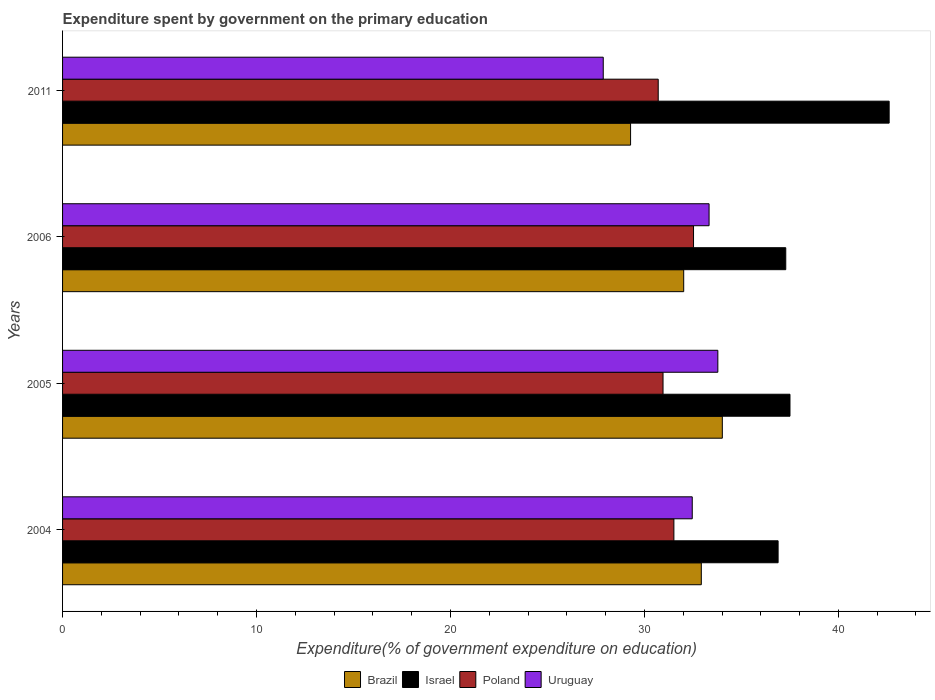How many different coloured bars are there?
Your response must be concise. 4. How many groups of bars are there?
Your answer should be very brief. 4. Are the number of bars per tick equal to the number of legend labels?
Provide a succinct answer. Yes. What is the expenditure spent by government on the primary education in Israel in 2005?
Provide a short and direct response. 37.5. Across all years, what is the maximum expenditure spent by government on the primary education in Brazil?
Provide a short and direct response. 34.02. Across all years, what is the minimum expenditure spent by government on the primary education in Uruguay?
Your answer should be very brief. 27.88. In which year was the expenditure spent by government on the primary education in Israel maximum?
Ensure brevity in your answer.  2011. What is the total expenditure spent by government on the primary education in Brazil in the graph?
Ensure brevity in your answer.  128.26. What is the difference between the expenditure spent by government on the primary education in Israel in 2005 and that in 2006?
Provide a succinct answer. 0.22. What is the difference between the expenditure spent by government on the primary education in Brazil in 2004 and the expenditure spent by government on the primary education in Uruguay in 2006?
Keep it short and to the point. -0.4. What is the average expenditure spent by government on the primary education in Poland per year?
Provide a succinct answer. 31.43. In the year 2011, what is the difference between the expenditure spent by government on the primary education in Poland and expenditure spent by government on the primary education in Israel?
Offer a very short reply. -11.91. In how many years, is the expenditure spent by government on the primary education in Uruguay greater than 6 %?
Provide a succinct answer. 4. What is the ratio of the expenditure spent by government on the primary education in Brazil in 2004 to that in 2006?
Provide a short and direct response. 1.03. Is the difference between the expenditure spent by government on the primary education in Poland in 2004 and 2006 greater than the difference between the expenditure spent by government on the primary education in Israel in 2004 and 2006?
Your answer should be very brief. No. What is the difference between the highest and the second highest expenditure spent by government on the primary education in Poland?
Your answer should be compact. 1.01. What is the difference between the highest and the lowest expenditure spent by government on the primary education in Uruguay?
Provide a short and direct response. 5.91. In how many years, is the expenditure spent by government on the primary education in Brazil greater than the average expenditure spent by government on the primary education in Brazil taken over all years?
Make the answer very short. 2. What does the 4th bar from the bottom in 2011 represents?
Your answer should be very brief. Uruguay. Is it the case that in every year, the sum of the expenditure spent by government on the primary education in Uruguay and expenditure spent by government on the primary education in Poland is greater than the expenditure spent by government on the primary education in Brazil?
Keep it short and to the point. Yes. Are all the bars in the graph horizontal?
Give a very brief answer. Yes. Are the values on the major ticks of X-axis written in scientific E-notation?
Ensure brevity in your answer.  No. Does the graph contain any zero values?
Provide a short and direct response. No. Does the graph contain grids?
Make the answer very short. No. Where does the legend appear in the graph?
Offer a very short reply. Bottom center. How many legend labels are there?
Your answer should be compact. 4. What is the title of the graph?
Provide a short and direct response. Expenditure spent by government on the primary education. What is the label or title of the X-axis?
Your answer should be very brief. Expenditure(% of government expenditure on education). What is the label or title of the Y-axis?
Make the answer very short. Years. What is the Expenditure(% of government expenditure on education) in Brazil in 2004?
Provide a short and direct response. 32.93. What is the Expenditure(% of government expenditure on education) of Israel in 2004?
Provide a short and direct response. 36.89. What is the Expenditure(% of government expenditure on education) of Poland in 2004?
Your response must be concise. 31.52. What is the Expenditure(% of government expenditure on education) in Uruguay in 2004?
Your answer should be very brief. 32.47. What is the Expenditure(% of government expenditure on education) in Brazil in 2005?
Offer a very short reply. 34.02. What is the Expenditure(% of government expenditure on education) in Israel in 2005?
Keep it short and to the point. 37.5. What is the Expenditure(% of government expenditure on education) of Poland in 2005?
Keep it short and to the point. 30.96. What is the Expenditure(% of government expenditure on education) of Uruguay in 2005?
Ensure brevity in your answer.  33.78. What is the Expenditure(% of government expenditure on education) of Brazil in 2006?
Provide a short and direct response. 32.02. What is the Expenditure(% of government expenditure on education) in Israel in 2006?
Your answer should be very brief. 37.29. What is the Expenditure(% of government expenditure on education) of Poland in 2006?
Offer a terse response. 32.53. What is the Expenditure(% of government expenditure on education) in Uruguay in 2006?
Offer a very short reply. 33.33. What is the Expenditure(% of government expenditure on education) of Brazil in 2011?
Offer a very short reply. 29.29. What is the Expenditure(% of government expenditure on education) of Israel in 2011?
Give a very brief answer. 42.62. What is the Expenditure(% of government expenditure on education) of Poland in 2011?
Provide a short and direct response. 30.71. What is the Expenditure(% of government expenditure on education) of Uruguay in 2011?
Provide a succinct answer. 27.88. Across all years, what is the maximum Expenditure(% of government expenditure on education) of Brazil?
Offer a terse response. 34.02. Across all years, what is the maximum Expenditure(% of government expenditure on education) of Israel?
Offer a terse response. 42.62. Across all years, what is the maximum Expenditure(% of government expenditure on education) of Poland?
Offer a very short reply. 32.53. Across all years, what is the maximum Expenditure(% of government expenditure on education) in Uruguay?
Offer a terse response. 33.78. Across all years, what is the minimum Expenditure(% of government expenditure on education) of Brazil?
Your answer should be compact. 29.29. Across all years, what is the minimum Expenditure(% of government expenditure on education) in Israel?
Keep it short and to the point. 36.89. Across all years, what is the minimum Expenditure(% of government expenditure on education) of Poland?
Make the answer very short. 30.71. Across all years, what is the minimum Expenditure(% of government expenditure on education) of Uruguay?
Your answer should be very brief. 27.88. What is the total Expenditure(% of government expenditure on education) of Brazil in the graph?
Offer a very short reply. 128.26. What is the total Expenditure(% of government expenditure on education) in Israel in the graph?
Offer a terse response. 154.3. What is the total Expenditure(% of government expenditure on education) in Poland in the graph?
Provide a short and direct response. 125.72. What is the total Expenditure(% of government expenditure on education) in Uruguay in the graph?
Offer a very short reply. 127.46. What is the difference between the Expenditure(% of government expenditure on education) of Brazil in 2004 and that in 2005?
Your response must be concise. -1.08. What is the difference between the Expenditure(% of government expenditure on education) in Israel in 2004 and that in 2005?
Offer a very short reply. -0.61. What is the difference between the Expenditure(% of government expenditure on education) in Poland in 2004 and that in 2005?
Offer a terse response. 0.56. What is the difference between the Expenditure(% of government expenditure on education) of Uruguay in 2004 and that in 2005?
Provide a succinct answer. -1.32. What is the difference between the Expenditure(% of government expenditure on education) in Brazil in 2004 and that in 2006?
Keep it short and to the point. 0.91. What is the difference between the Expenditure(% of government expenditure on education) in Israel in 2004 and that in 2006?
Provide a short and direct response. -0.4. What is the difference between the Expenditure(% of government expenditure on education) of Poland in 2004 and that in 2006?
Provide a succinct answer. -1.01. What is the difference between the Expenditure(% of government expenditure on education) in Uruguay in 2004 and that in 2006?
Your response must be concise. -0.87. What is the difference between the Expenditure(% of government expenditure on education) of Brazil in 2004 and that in 2011?
Ensure brevity in your answer.  3.65. What is the difference between the Expenditure(% of government expenditure on education) in Israel in 2004 and that in 2011?
Offer a very short reply. -5.73. What is the difference between the Expenditure(% of government expenditure on education) of Poland in 2004 and that in 2011?
Make the answer very short. 0.81. What is the difference between the Expenditure(% of government expenditure on education) of Uruguay in 2004 and that in 2011?
Provide a short and direct response. 4.59. What is the difference between the Expenditure(% of government expenditure on education) in Brazil in 2005 and that in 2006?
Your answer should be compact. 1.99. What is the difference between the Expenditure(% of government expenditure on education) of Israel in 2005 and that in 2006?
Offer a terse response. 0.22. What is the difference between the Expenditure(% of government expenditure on education) of Poland in 2005 and that in 2006?
Provide a short and direct response. -1.57. What is the difference between the Expenditure(% of government expenditure on education) in Uruguay in 2005 and that in 2006?
Keep it short and to the point. 0.45. What is the difference between the Expenditure(% of government expenditure on education) of Brazil in 2005 and that in 2011?
Keep it short and to the point. 4.73. What is the difference between the Expenditure(% of government expenditure on education) in Israel in 2005 and that in 2011?
Your answer should be very brief. -5.11. What is the difference between the Expenditure(% of government expenditure on education) in Poland in 2005 and that in 2011?
Your answer should be compact. 0.25. What is the difference between the Expenditure(% of government expenditure on education) in Uruguay in 2005 and that in 2011?
Provide a succinct answer. 5.91. What is the difference between the Expenditure(% of government expenditure on education) in Brazil in 2006 and that in 2011?
Provide a short and direct response. 2.74. What is the difference between the Expenditure(% of government expenditure on education) of Israel in 2006 and that in 2011?
Keep it short and to the point. -5.33. What is the difference between the Expenditure(% of government expenditure on education) of Poland in 2006 and that in 2011?
Give a very brief answer. 1.82. What is the difference between the Expenditure(% of government expenditure on education) in Uruguay in 2006 and that in 2011?
Ensure brevity in your answer.  5.46. What is the difference between the Expenditure(% of government expenditure on education) in Brazil in 2004 and the Expenditure(% of government expenditure on education) in Israel in 2005?
Your response must be concise. -4.57. What is the difference between the Expenditure(% of government expenditure on education) in Brazil in 2004 and the Expenditure(% of government expenditure on education) in Poland in 2005?
Make the answer very short. 1.97. What is the difference between the Expenditure(% of government expenditure on education) of Brazil in 2004 and the Expenditure(% of government expenditure on education) of Uruguay in 2005?
Give a very brief answer. -0.85. What is the difference between the Expenditure(% of government expenditure on education) in Israel in 2004 and the Expenditure(% of government expenditure on education) in Poland in 2005?
Your response must be concise. 5.93. What is the difference between the Expenditure(% of government expenditure on education) of Israel in 2004 and the Expenditure(% of government expenditure on education) of Uruguay in 2005?
Your response must be concise. 3.11. What is the difference between the Expenditure(% of government expenditure on education) in Poland in 2004 and the Expenditure(% of government expenditure on education) in Uruguay in 2005?
Provide a short and direct response. -2.27. What is the difference between the Expenditure(% of government expenditure on education) of Brazil in 2004 and the Expenditure(% of government expenditure on education) of Israel in 2006?
Keep it short and to the point. -4.35. What is the difference between the Expenditure(% of government expenditure on education) of Brazil in 2004 and the Expenditure(% of government expenditure on education) of Poland in 2006?
Offer a very short reply. 0.4. What is the difference between the Expenditure(% of government expenditure on education) in Brazil in 2004 and the Expenditure(% of government expenditure on education) in Uruguay in 2006?
Your answer should be compact. -0.4. What is the difference between the Expenditure(% of government expenditure on education) of Israel in 2004 and the Expenditure(% of government expenditure on education) of Poland in 2006?
Offer a terse response. 4.36. What is the difference between the Expenditure(% of government expenditure on education) in Israel in 2004 and the Expenditure(% of government expenditure on education) in Uruguay in 2006?
Ensure brevity in your answer.  3.56. What is the difference between the Expenditure(% of government expenditure on education) in Poland in 2004 and the Expenditure(% of government expenditure on education) in Uruguay in 2006?
Your response must be concise. -1.81. What is the difference between the Expenditure(% of government expenditure on education) of Brazil in 2004 and the Expenditure(% of government expenditure on education) of Israel in 2011?
Your answer should be compact. -9.69. What is the difference between the Expenditure(% of government expenditure on education) in Brazil in 2004 and the Expenditure(% of government expenditure on education) in Poland in 2011?
Provide a succinct answer. 2.22. What is the difference between the Expenditure(% of government expenditure on education) of Brazil in 2004 and the Expenditure(% of government expenditure on education) of Uruguay in 2011?
Provide a succinct answer. 5.06. What is the difference between the Expenditure(% of government expenditure on education) of Israel in 2004 and the Expenditure(% of government expenditure on education) of Poland in 2011?
Your response must be concise. 6.18. What is the difference between the Expenditure(% of government expenditure on education) of Israel in 2004 and the Expenditure(% of government expenditure on education) of Uruguay in 2011?
Your answer should be compact. 9.02. What is the difference between the Expenditure(% of government expenditure on education) of Poland in 2004 and the Expenditure(% of government expenditure on education) of Uruguay in 2011?
Offer a very short reply. 3.64. What is the difference between the Expenditure(% of government expenditure on education) of Brazil in 2005 and the Expenditure(% of government expenditure on education) of Israel in 2006?
Make the answer very short. -3.27. What is the difference between the Expenditure(% of government expenditure on education) of Brazil in 2005 and the Expenditure(% of government expenditure on education) of Poland in 2006?
Your answer should be very brief. 1.48. What is the difference between the Expenditure(% of government expenditure on education) of Brazil in 2005 and the Expenditure(% of government expenditure on education) of Uruguay in 2006?
Provide a succinct answer. 0.68. What is the difference between the Expenditure(% of government expenditure on education) in Israel in 2005 and the Expenditure(% of government expenditure on education) in Poland in 2006?
Provide a succinct answer. 4.97. What is the difference between the Expenditure(% of government expenditure on education) in Israel in 2005 and the Expenditure(% of government expenditure on education) in Uruguay in 2006?
Provide a succinct answer. 4.17. What is the difference between the Expenditure(% of government expenditure on education) in Poland in 2005 and the Expenditure(% of government expenditure on education) in Uruguay in 2006?
Your answer should be compact. -2.37. What is the difference between the Expenditure(% of government expenditure on education) in Brazil in 2005 and the Expenditure(% of government expenditure on education) in Israel in 2011?
Give a very brief answer. -8.6. What is the difference between the Expenditure(% of government expenditure on education) in Brazil in 2005 and the Expenditure(% of government expenditure on education) in Poland in 2011?
Offer a very short reply. 3.31. What is the difference between the Expenditure(% of government expenditure on education) of Brazil in 2005 and the Expenditure(% of government expenditure on education) of Uruguay in 2011?
Your answer should be compact. 6.14. What is the difference between the Expenditure(% of government expenditure on education) of Israel in 2005 and the Expenditure(% of government expenditure on education) of Poland in 2011?
Offer a very short reply. 6.79. What is the difference between the Expenditure(% of government expenditure on education) of Israel in 2005 and the Expenditure(% of government expenditure on education) of Uruguay in 2011?
Provide a succinct answer. 9.63. What is the difference between the Expenditure(% of government expenditure on education) of Poland in 2005 and the Expenditure(% of government expenditure on education) of Uruguay in 2011?
Make the answer very short. 3.08. What is the difference between the Expenditure(% of government expenditure on education) of Brazil in 2006 and the Expenditure(% of government expenditure on education) of Israel in 2011?
Make the answer very short. -10.59. What is the difference between the Expenditure(% of government expenditure on education) of Brazil in 2006 and the Expenditure(% of government expenditure on education) of Poland in 2011?
Your answer should be very brief. 1.31. What is the difference between the Expenditure(% of government expenditure on education) in Brazil in 2006 and the Expenditure(% of government expenditure on education) in Uruguay in 2011?
Offer a terse response. 4.15. What is the difference between the Expenditure(% of government expenditure on education) of Israel in 2006 and the Expenditure(% of government expenditure on education) of Poland in 2011?
Provide a short and direct response. 6.58. What is the difference between the Expenditure(% of government expenditure on education) of Israel in 2006 and the Expenditure(% of government expenditure on education) of Uruguay in 2011?
Offer a very short reply. 9.41. What is the difference between the Expenditure(% of government expenditure on education) in Poland in 2006 and the Expenditure(% of government expenditure on education) in Uruguay in 2011?
Offer a terse response. 4.65. What is the average Expenditure(% of government expenditure on education) in Brazil per year?
Provide a succinct answer. 32.06. What is the average Expenditure(% of government expenditure on education) of Israel per year?
Your response must be concise. 38.58. What is the average Expenditure(% of government expenditure on education) in Poland per year?
Give a very brief answer. 31.43. What is the average Expenditure(% of government expenditure on education) of Uruguay per year?
Provide a succinct answer. 31.86. In the year 2004, what is the difference between the Expenditure(% of government expenditure on education) in Brazil and Expenditure(% of government expenditure on education) in Israel?
Your answer should be very brief. -3.96. In the year 2004, what is the difference between the Expenditure(% of government expenditure on education) of Brazil and Expenditure(% of government expenditure on education) of Poland?
Offer a terse response. 1.41. In the year 2004, what is the difference between the Expenditure(% of government expenditure on education) in Brazil and Expenditure(% of government expenditure on education) in Uruguay?
Offer a very short reply. 0.47. In the year 2004, what is the difference between the Expenditure(% of government expenditure on education) in Israel and Expenditure(% of government expenditure on education) in Poland?
Keep it short and to the point. 5.37. In the year 2004, what is the difference between the Expenditure(% of government expenditure on education) in Israel and Expenditure(% of government expenditure on education) in Uruguay?
Your answer should be compact. 4.43. In the year 2004, what is the difference between the Expenditure(% of government expenditure on education) in Poland and Expenditure(% of government expenditure on education) in Uruguay?
Your answer should be compact. -0.95. In the year 2005, what is the difference between the Expenditure(% of government expenditure on education) of Brazil and Expenditure(% of government expenditure on education) of Israel?
Ensure brevity in your answer.  -3.49. In the year 2005, what is the difference between the Expenditure(% of government expenditure on education) in Brazil and Expenditure(% of government expenditure on education) in Poland?
Provide a short and direct response. 3.06. In the year 2005, what is the difference between the Expenditure(% of government expenditure on education) of Brazil and Expenditure(% of government expenditure on education) of Uruguay?
Your response must be concise. 0.23. In the year 2005, what is the difference between the Expenditure(% of government expenditure on education) of Israel and Expenditure(% of government expenditure on education) of Poland?
Give a very brief answer. 6.55. In the year 2005, what is the difference between the Expenditure(% of government expenditure on education) of Israel and Expenditure(% of government expenditure on education) of Uruguay?
Your answer should be very brief. 3.72. In the year 2005, what is the difference between the Expenditure(% of government expenditure on education) in Poland and Expenditure(% of government expenditure on education) in Uruguay?
Ensure brevity in your answer.  -2.83. In the year 2006, what is the difference between the Expenditure(% of government expenditure on education) in Brazil and Expenditure(% of government expenditure on education) in Israel?
Provide a short and direct response. -5.26. In the year 2006, what is the difference between the Expenditure(% of government expenditure on education) of Brazil and Expenditure(% of government expenditure on education) of Poland?
Provide a succinct answer. -0.51. In the year 2006, what is the difference between the Expenditure(% of government expenditure on education) of Brazil and Expenditure(% of government expenditure on education) of Uruguay?
Make the answer very short. -1.31. In the year 2006, what is the difference between the Expenditure(% of government expenditure on education) in Israel and Expenditure(% of government expenditure on education) in Poland?
Your answer should be very brief. 4.76. In the year 2006, what is the difference between the Expenditure(% of government expenditure on education) in Israel and Expenditure(% of government expenditure on education) in Uruguay?
Ensure brevity in your answer.  3.95. In the year 2006, what is the difference between the Expenditure(% of government expenditure on education) of Poland and Expenditure(% of government expenditure on education) of Uruguay?
Provide a short and direct response. -0.8. In the year 2011, what is the difference between the Expenditure(% of government expenditure on education) in Brazil and Expenditure(% of government expenditure on education) in Israel?
Provide a succinct answer. -13.33. In the year 2011, what is the difference between the Expenditure(% of government expenditure on education) in Brazil and Expenditure(% of government expenditure on education) in Poland?
Keep it short and to the point. -1.43. In the year 2011, what is the difference between the Expenditure(% of government expenditure on education) in Brazil and Expenditure(% of government expenditure on education) in Uruguay?
Offer a very short reply. 1.41. In the year 2011, what is the difference between the Expenditure(% of government expenditure on education) of Israel and Expenditure(% of government expenditure on education) of Poland?
Provide a short and direct response. 11.91. In the year 2011, what is the difference between the Expenditure(% of government expenditure on education) in Israel and Expenditure(% of government expenditure on education) in Uruguay?
Offer a very short reply. 14.74. In the year 2011, what is the difference between the Expenditure(% of government expenditure on education) of Poland and Expenditure(% of government expenditure on education) of Uruguay?
Keep it short and to the point. 2.83. What is the ratio of the Expenditure(% of government expenditure on education) in Brazil in 2004 to that in 2005?
Give a very brief answer. 0.97. What is the ratio of the Expenditure(% of government expenditure on education) of Israel in 2004 to that in 2005?
Ensure brevity in your answer.  0.98. What is the ratio of the Expenditure(% of government expenditure on education) in Poland in 2004 to that in 2005?
Your response must be concise. 1.02. What is the ratio of the Expenditure(% of government expenditure on education) of Uruguay in 2004 to that in 2005?
Ensure brevity in your answer.  0.96. What is the ratio of the Expenditure(% of government expenditure on education) in Brazil in 2004 to that in 2006?
Your response must be concise. 1.03. What is the ratio of the Expenditure(% of government expenditure on education) of Israel in 2004 to that in 2006?
Provide a succinct answer. 0.99. What is the ratio of the Expenditure(% of government expenditure on education) in Poland in 2004 to that in 2006?
Your response must be concise. 0.97. What is the ratio of the Expenditure(% of government expenditure on education) of Uruguay in 2004 to that in 2006?
Offer a very short reply. 0.97. What is the ratio of the Expenditure(% of government expenditure on education) in Brazil in 2004 to that in 2011?
Keep it short and to the point. 1.12. What is the ratio of the Expenditure(% of government expenditure on education) in Israel in 2004 to that in 2011?
Offer a very short reply. 0.87. What is the ratio of the Expenditure(% of government expenditure on education) in Poland in 2004 to that in 2011?
Give a very brief answer. 1.03. What is the ratio of the Expenditure(% of government expenditure on education) in Uruguay in 2004 to that in 2011?
Your answer should be compact. 1.16. What is the ratio of the Expenditure(% of government expenditure on education) in Brazil in 2005 to that in 2006?
Provide a succinct answer. 1.06. What is the ratio of the Expenditure(% of government expenditure on education) in Israel in 2005 to that in 2006?
Keep it short and to the point. 1.01. What is the ratio of the Expenditure(% of government expenditure on education) of Poland in 2005 to that in 2006?
Keep it short and to the point. 0.95. What is the ratio of the Expenditure(% of government expenditure on education) in Uruguay in 2005 to that in 2006?
Your response must be concise. 1.01. What is the ratio of the Expenditure(% of government expenditure on education) of Brazil in 2005 to that in 2011?
Make the answer very short. 1.16. What is the ratio of the Expenditure(% of government expenditure on education) of Poland in 2005 to that in 2011?
Your answer should be very brief. 1.01. What is the ratio of the Expenditure(% of government expenditure on education) of Uruguay in 2005 to that in 2011?
Make the answer very short. 1.21. What is the ratio of the Expenditure(% of government expenditure on education) of Brazil in 2006 to that in 2011?
Keep it short and to the point. 1.09. What is the ratio of the Expenditure(% of government expenditure on education) of Israel in 2006 to that in 2011?
Provide a succinct answer. 0.87. What is the ratio of the Expenditure(% of government expenditure on education) of Poland in 2006 to that in 2011?
Give a very brief answer. 1.06. What is the ratio of the Expenditure(% of government expenditure on education) in Uruguay in 2006 to that in 2011?
Provide a succinct answer. 1.2. What is the difference between the highest and the second highest Expenditure(% of government expenditure on education) in Brazil?
Your answer should be compact. 1.08. What is the difference between the highest and the second highest Expenditure(% of government expenditure on education) in Israel?
Your response must be concise. 5.11. What is the difference between the highest and the second highest Expenditure(% of government expenditure on education) in Poland?
Your answer should be very brief. 1.01. What is the difference between the highest and the second highest Expenditure(% of government expenditure on education) of Uruguay?
Offer a terse response. 0.45. What is the difference between the highest and the lowest Expenditure(% of government expenditure on education) in Brazil?
Ensure brevity in your answer.  4.73. What is the difference between the highest and the lowest Expenditure(% of government expenditure on education) of Israel?
Your answer should be very brief. 5.73. What is the difference between the highest and the lowest Expenditure(% of government expenditure on education) in Poland?
Your answer should be very brief. 1.82. What is the difference between the highest and the lowest Expenditure(% of government expenditure on education) of Uruguay?
Your answer should be very brief. 5.91. 